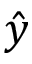<formula> <loc_0><loc_0><loc_500><loc_500>\hat { y }</formula> 